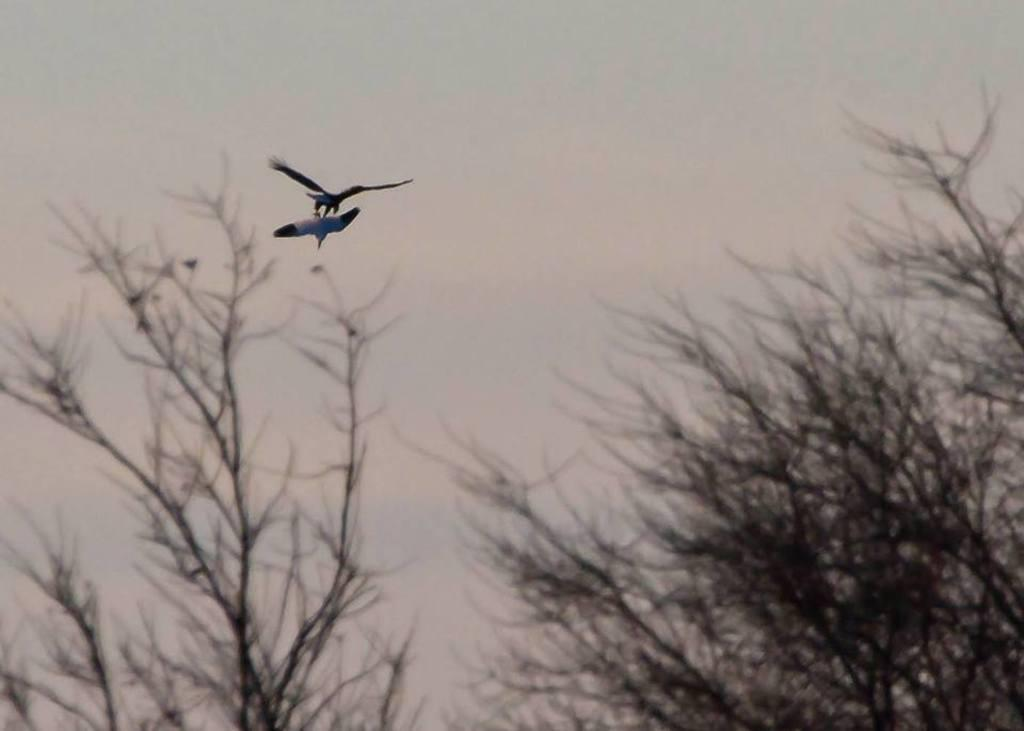What type of vegetation is present at the bottom of the image? There are trees at the bottom of the image. What can be seen at the top of the image? There is a sky visible at the top of the image. What animals are flying at the left side of the image? There are two birds flying at the left side of the image. What type of haircut do the trees have in the image? Trees do not have haircuts, as they are plants and not people. Are there any trousers visible on the birds in the image? There are no trousers present in the image, as birds do not wear clothing. 